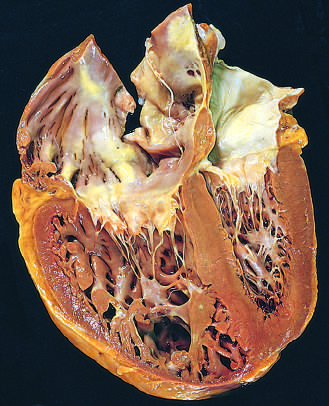what have been distorted by the enlarged right ventricle?
Answer the question using a single word or phrase. The shape and volume of the left ventricle 